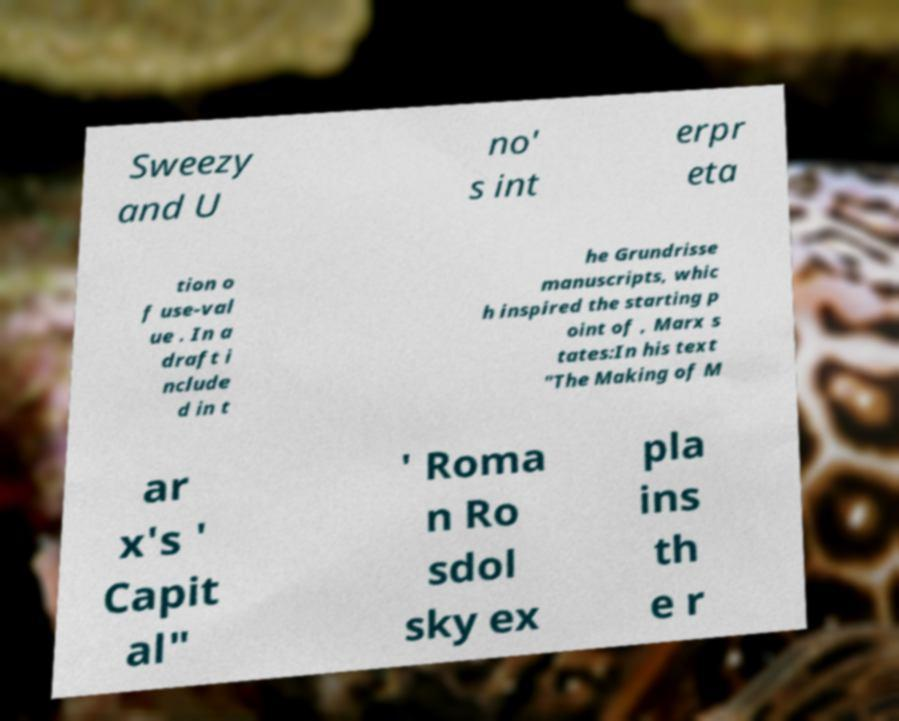Could you extract and type out the text from this image? Sweezy and U no' s int erpr eta tion o f use-val ue . In a draft i nclude d in t he Grundrisse manuscripts, whic h inspired the starting p oint of , Marx s tates:In his text "The Making of M ar x's ' Capit al" ' Roma n Ro sdol sky ex pla ins th e r 